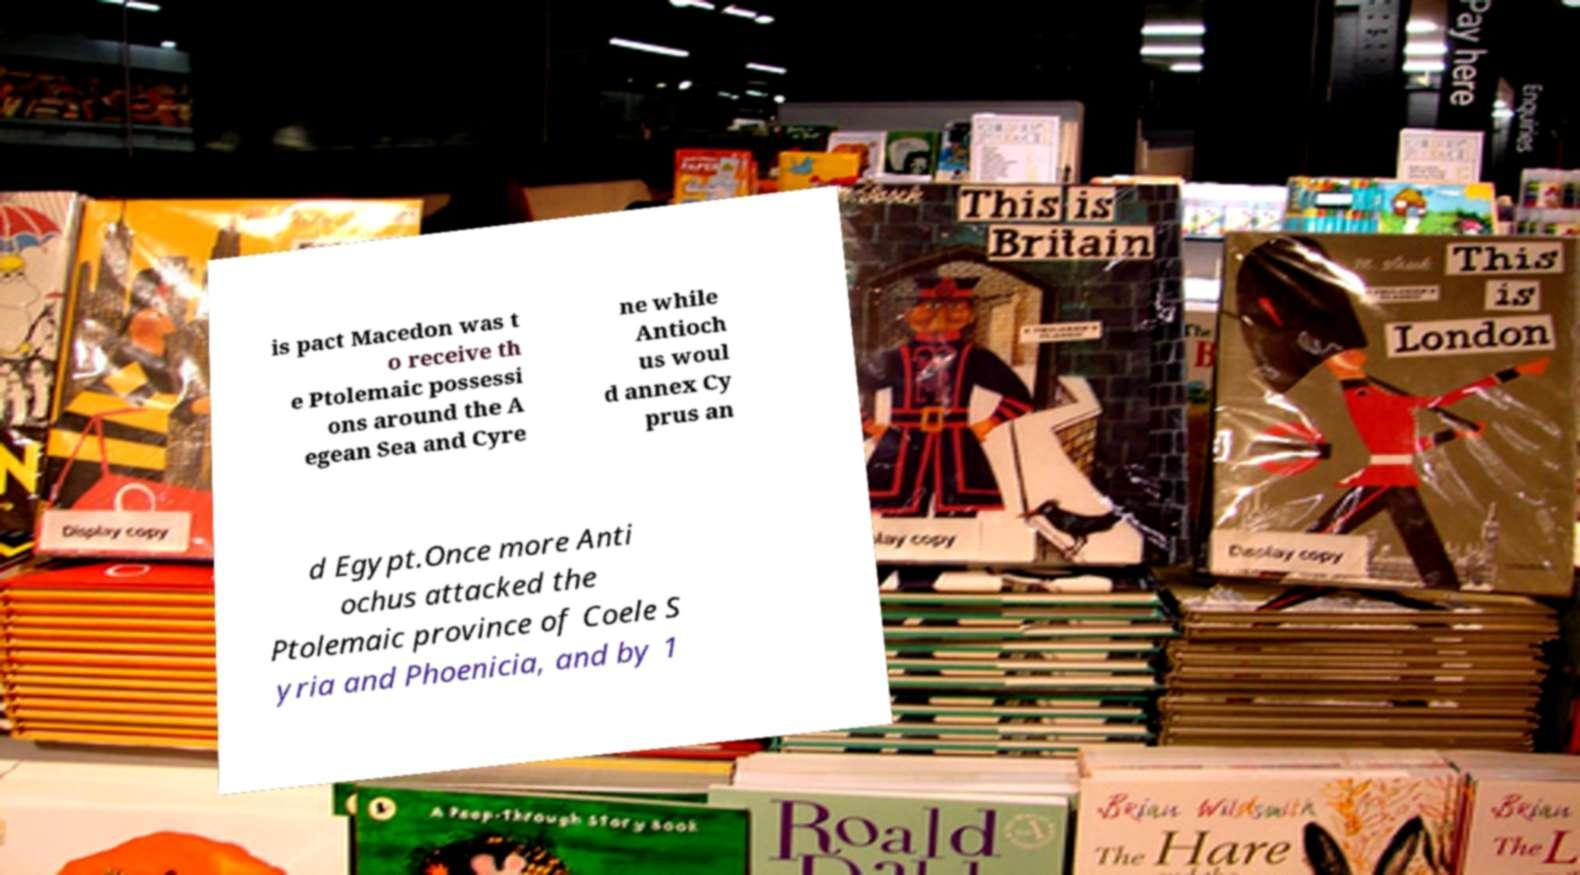I need the written content from this picture converted into text. Can you do that? is pact Macedon was t o receive th e Ptolemaic possessi ons around the A egean Sea and Cyre ne while Antioch us woul d annex Cy prus an d Egypt.Once more Anti ochus attacked the Ptolemaic province of Coele S yria and Phoenicia, and by 1 